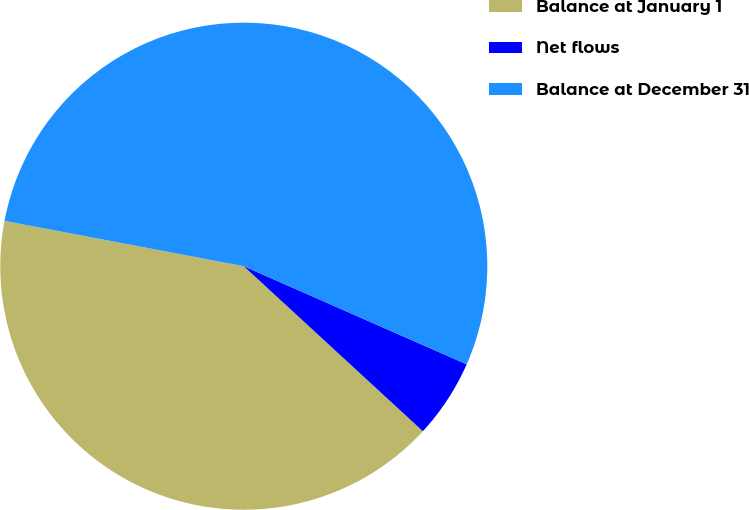Convert chart. <chart><loc_0><loc_0><loc_500><loc_500><pie_chart><fcel>Balance at January 1<fcel>Net flows<fcel>Balance at December 31<nl><fcel>41.13%<fcel>5.25%<fcel>53.62%<nl></chart> 